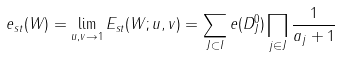Convert formula to latex. <formula><loc_0><loc_0><loc_500><loc_500>e _ { s t } ( W ) = \lim _ { u , v \to 1 } E _ { s t } ( W ; u , v ) = \sum _ { J \subset I } e ( D _ { J } ^ { 0 } ) \prod _ { j \in J } \frac { 1 } { a _ { j } + 1 }</formula> 